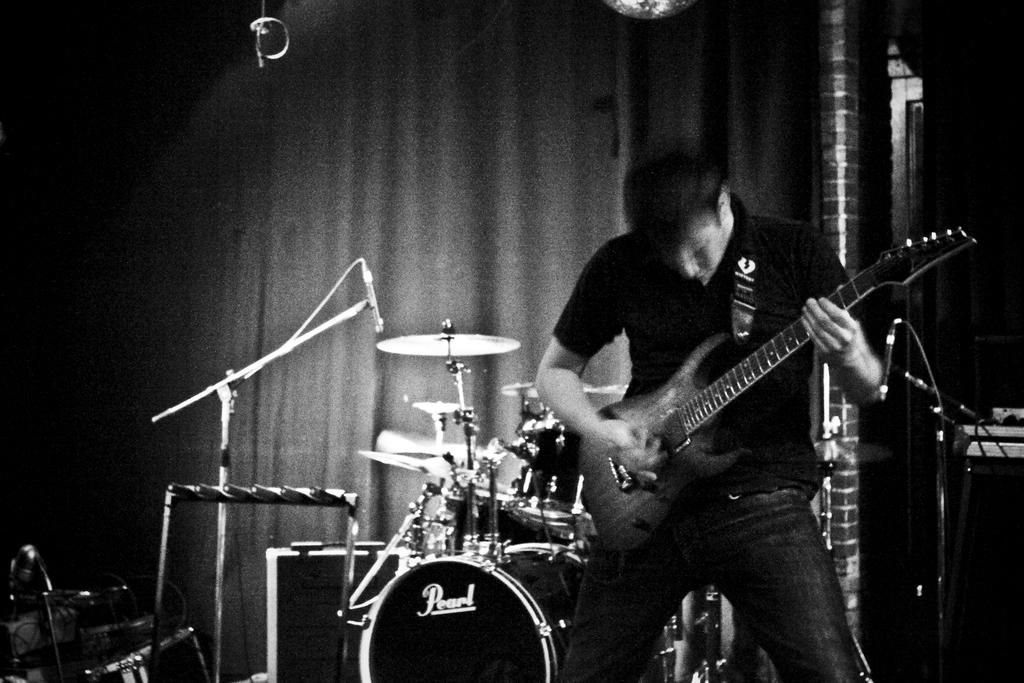What is the main activity being performed by the person in the image? The person in the image is playing a guitar. What other musical instruments can be seen in the image? There are many musical instruments visible in the background of the image. What type of class is being held in the image? There is no class being held in the image; it features a person playing a guitar and other musical instruments in the background. How does the kitten contribute to the musical performance in the image? There is no kitten present in the image, so it cannot contribute to the musical performance. 